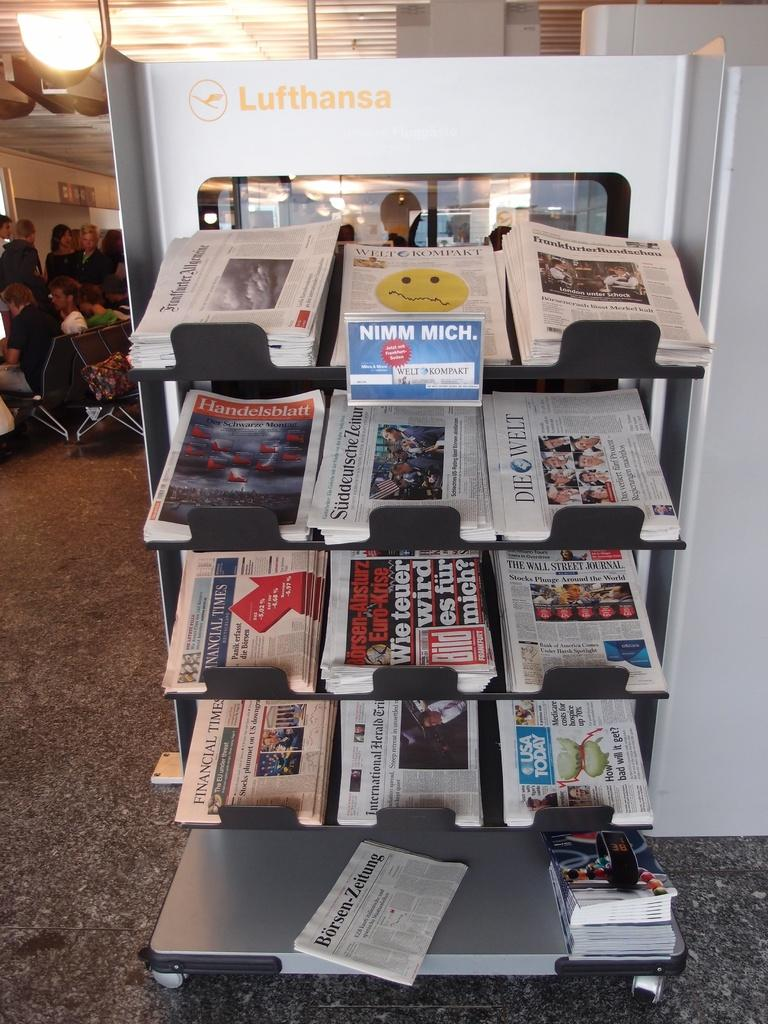<image>
Provide a brief description of the given image. a newpaper shelf has the USA today near the bottom 